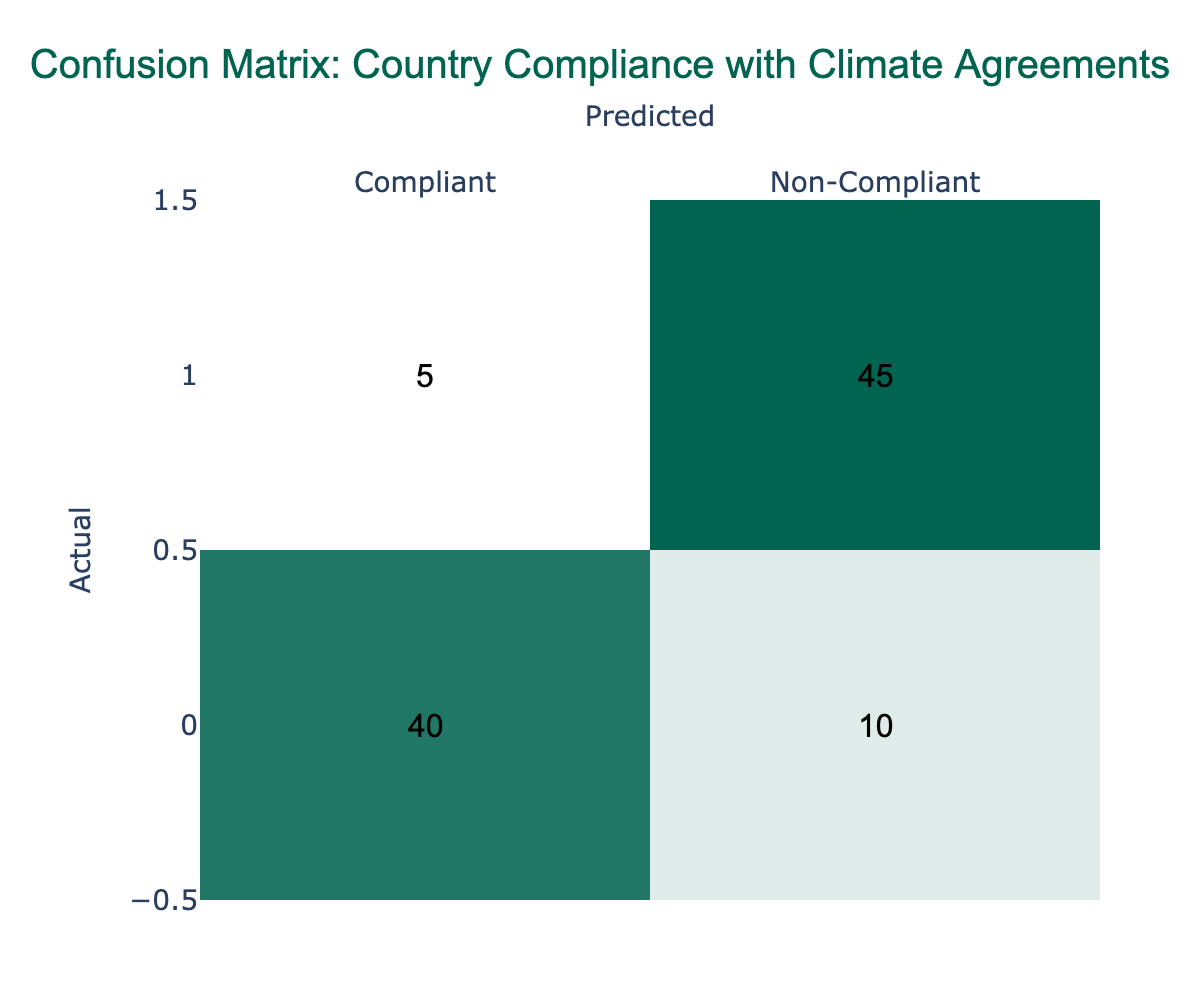What is the total number of countries predicted to be compliant? To find the total predicted compliant countries, we look at the column marked "Compliant" in the predicted row. There are 40 countries predicted to be compliant.
Answer: 40 What is the total number of actual non-compliant countries? By examining the row labeled "Non-Compliant," we can see that there are 5 countries that were predicted to be compliant and 45 that were predicted to be non-compliant. Therefore, the total is 5 + 45 = 50.
Answer: 50 How many countries were misclassified as compliant? The number of countries misclassified as compliant is found in the cell corresponding to "Actual Non-Compliant" and "Predicted Compliant", which shows 5 countries.
Answer: 5 Is it true that more countries are correctly classified as non-compliant than as compliant? We check the "Actual" rows for both compliant and non-compliant classifications. There are 45 non-compliant countries correctly classified compared to 40 compliant countries. As 45 > 40, the statement is true.
Answer: Yes What is the overall prediction accuracy based on this confusion matrix? The total number of true predictions (compliant and non-compliant) is 40 (true positives) + 45 (true negatives) = 85. The overall total predictions are 40 + 10 + 5 + 45 = 100. Therefore, accuracy is 85/100 = 0.85 or 85%.
Answer: 85% How many more countries were predicted to be non-compliant than actually were compliant? We take the difference between the predicted non-compliant (55) and actual compliant (40) countries: 55 - 40 = 15. Thus, 15 more countries were predicted to be non-compliant than actually were compliant.
Answer: 15 What percentage of the total predictions were incorrectly classified? The total incorrect predictions comprise 10 (false positives) + 5 (false negatives) = 15. Total predictions are 100. Thus, the percentage of incorrect classifications is (15/100) * 100 = 15%.
Answer: 15% If 10 more countries are added to the actual compliant category, what would be the new total of predicted compliant countries? The new actual compliant count would be 40 + 10 = 50. The predicted compliant is still based on the table and remains at 40. Therefore, despite the change in actuals, the predicted value does not change.
Answer: 40 How many countries are accurately identified in total? The total accurately identified countries is the sum of true positives and true negatives: 40 (actual compliant correctly predicted) + 45 (actual non-compliant correctly predicted) = 85.
Answer: 85 